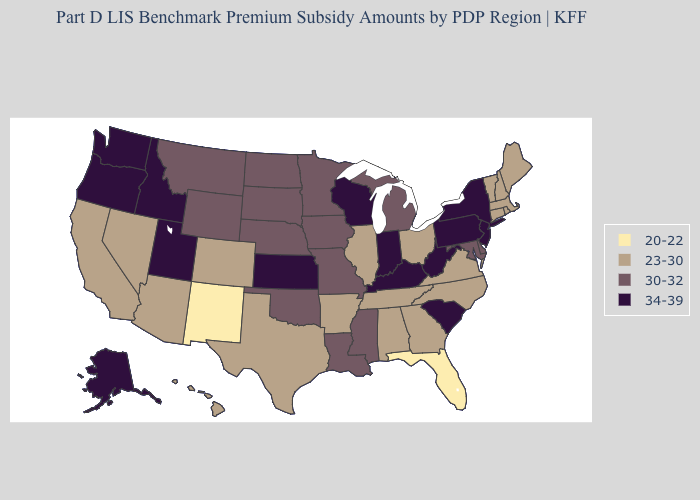Does New York have the lowest value in the Northeast?
Be succinct. No. What is the value of Idaho?
Answer briefly. 34-39. Name the states that have a value in the range 23-30?
Be succinct. Alabama, Arizona, Arkansas, California, Colorado, Connecticut, Georgia, Hawaii, Illinois, Maine, Massachusetts, Nevada, New Hampshire, North Carolina, Ohio, Rhode Island, Tennessee, Texas, Vermont, Virginia. What is the value of Pennsylvania?
Give a very brief answer. 34-39. Name the states that have a value in the range 34-39?
Be succinct. Alaska, Idaho, Indiana, Kansas, Kentucky, New Jersey, New York, Oregon, Pennsylvania, South Carolina, Utah, Washington, West Virginia, Wisconsin. Which states hav the highest value in the South?
Be succinct. Kentucky, South Carolina, West Virginia. What is the highest value in the South ?
Quick response, please. 34-39. What is the highest value in states that border Tennessee?
Be succinct. 34-39. What is the lowest value in the MidWest?
Be succinct. 23-30. What is the lowest value in the USA?
Write a very short answer. 20-22. Does the map have missing data?
Answer briefly. No. What is the value of Georgia?
Answer briefly. 23-30. Does Florida have a lower value than New Mexico?
Concise answer only. No. What is the value of Montana?
Answer briefly. 30-32. What is the value of Arizona?
Answer briefly. 23-30. 